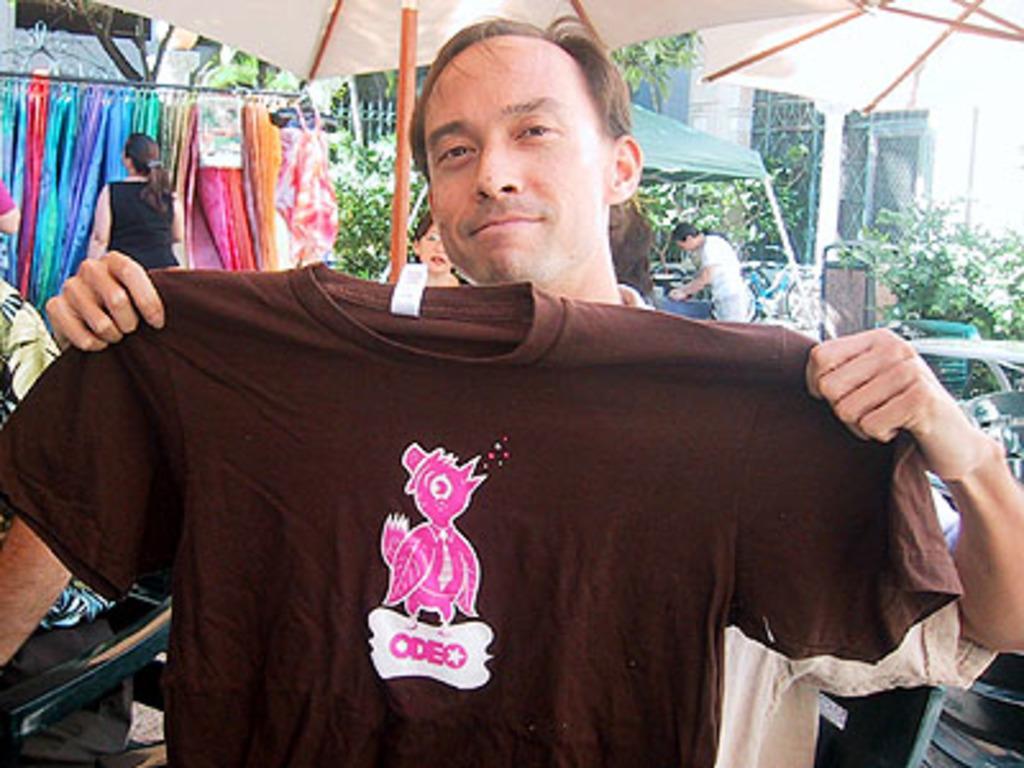Could you give a brief overview of what you see in this image? In the middle of the image a person is standing and holding a T-shirt. Behind him we can see some tents, clothes and few people are standing. Behind them we can see some plants, trees and buildings. 